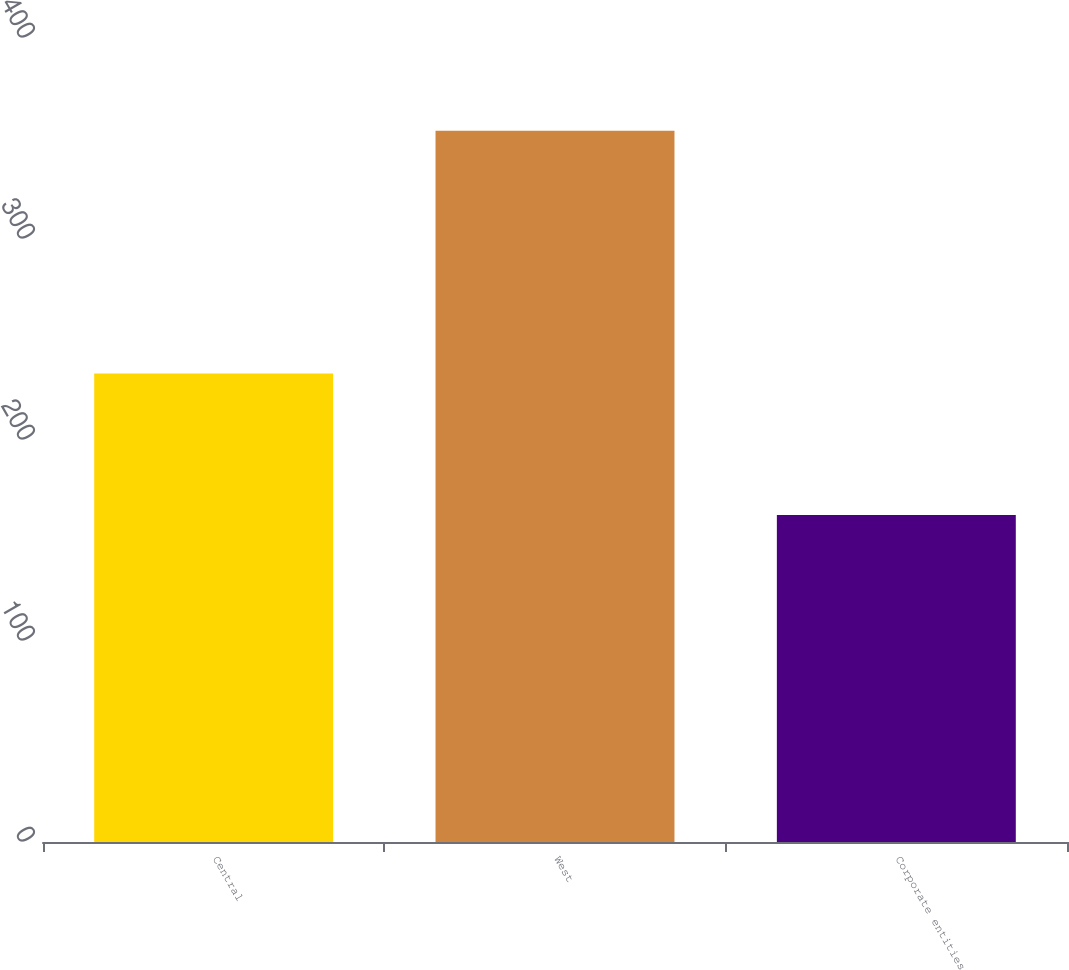Convert chart. <chart><loc_0><loc_0><loc_500><loc_500><bar_chart><fcel>Central<fcel>West<fcel>Corporate entities<nl><fcel>233.1<fcel>353.8<fcel>162.7<nl></chart> 